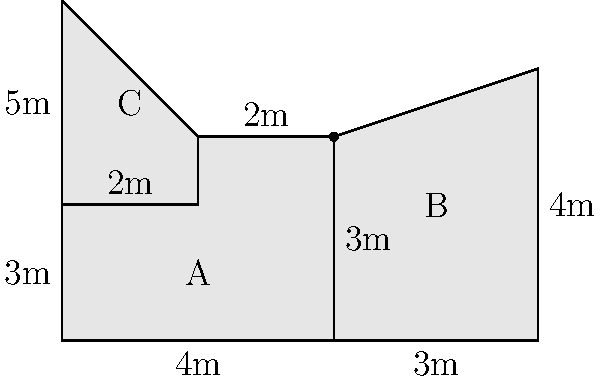In your deconstructivist-inspired building, you have an irregularly shaped floor plan composed of three connected areas (A, B, and C) as shown in the diagram. Given the measurements provided, calculate the total floor area in square meters. To calculate the total floor area, we need to sum the areas of the three irregular shapes:

1. Area A:
   This is a rectangle with a rectangular cutout.
   Area = $(4 \times 3) - (2 \times 1) = 12 - 2 = 10$ m²

2. Area B:
   This is a trapezoid.
   Area = $\frac{1}{2}(3 + 4) \times 3 = \frac{1}{2} \times 7 \times 3 = 10.5$ m²

3. Area C:
   This is a triangle.
   Area = $\frac{1}{2} \times 2 \times 3 = 3$ m²

Total floor area:
$$ \text{Total Area} = 10 + 10.5 + 3 = 23.5 \text{ m²} $$
Answer: 23.5 m² 